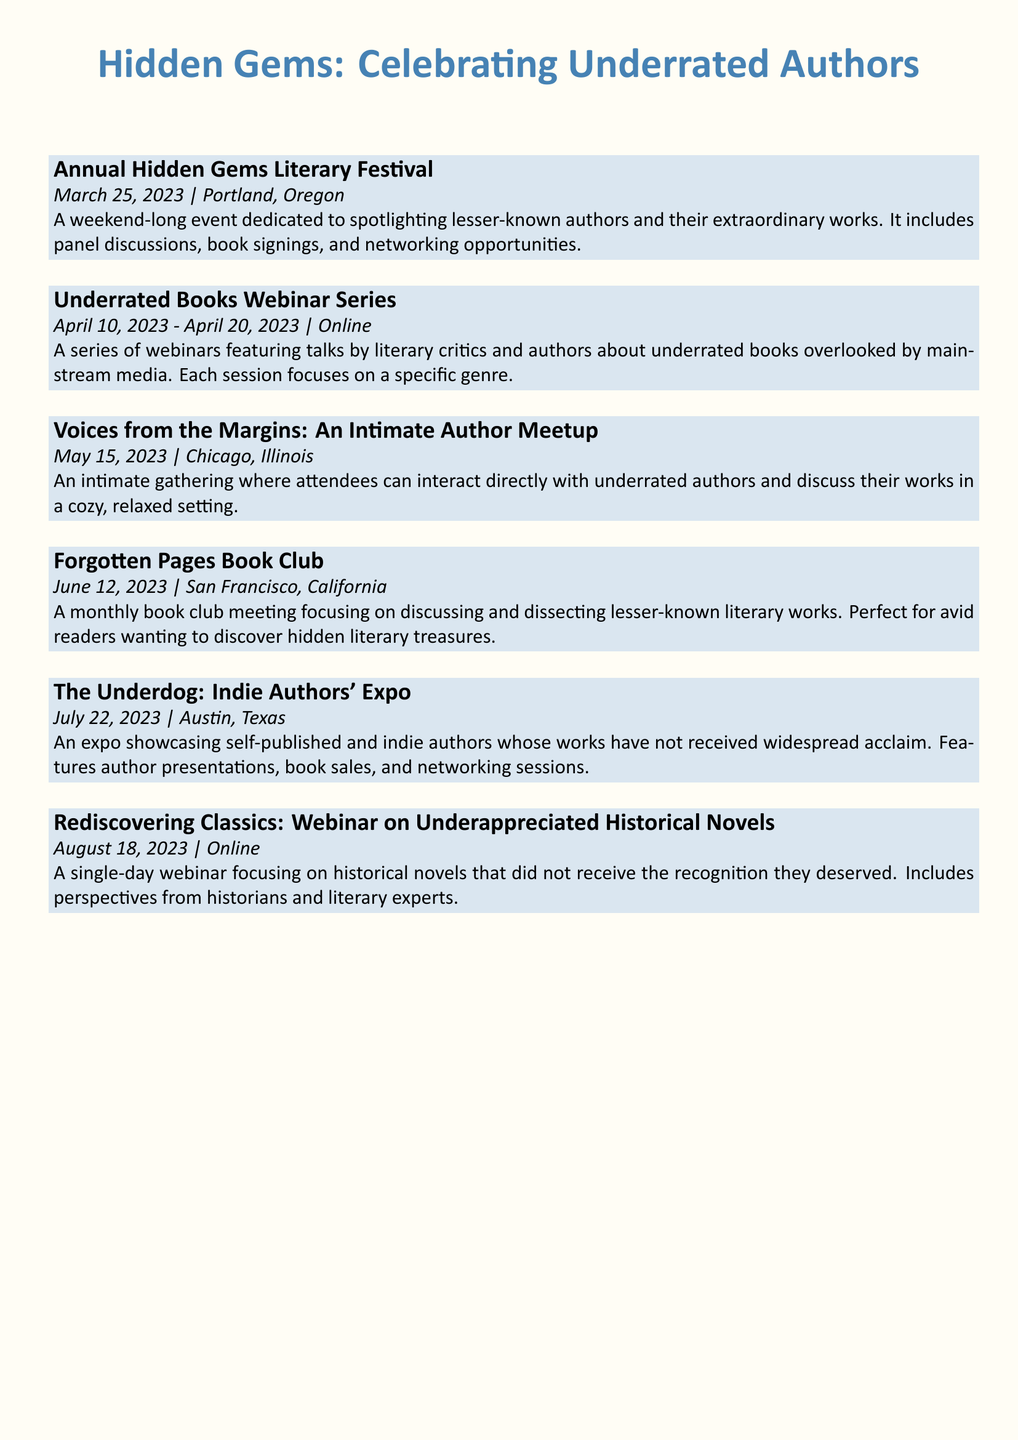What is the date of the Annual Hidden Gems Literary Festival? The document lists the date for the festival, which is March 25, 2023.
Answer: March 25, 2023 Where is the Underrated Books Webinar Series held? The document specifies that this series takes place online.
Answer: Online What is the focus of the Voices from the Margins meetup? The event description indicates that it allows interaction with underrated authors and discussions about their works.
Answer: Interaction with underrated authors How many authors are featured at The Underdog: Indie Authors' Expo? The document does not specify a number but mentions showcasing self-published and indie authors.
Answer: Indie authors What month is the Forgotten Pages Book Club meeting scheduled for? The document provides the date, which is June 12, 2023.
Answer: June What type of literature does the Rediscovering Classics webinar focus on? The description indicates it focuses on underappreciated historical novels.
Answer: Historical novels What is the location of the The Underdog: Indie Authors' Expo? The exposition is stated to be in Austin, Texas.
Answer: Austin, Texas Which event includes panel discussions? The Annual Hidden Gems Literary Festival is the event that includes panel discussions.
Answer: Annual Hidden Gems Literary Festival When is the meeting for the Forgotten Pages Book Club? The document states the meeting is on June 12, 2023.
Answer: June 12, 2023 